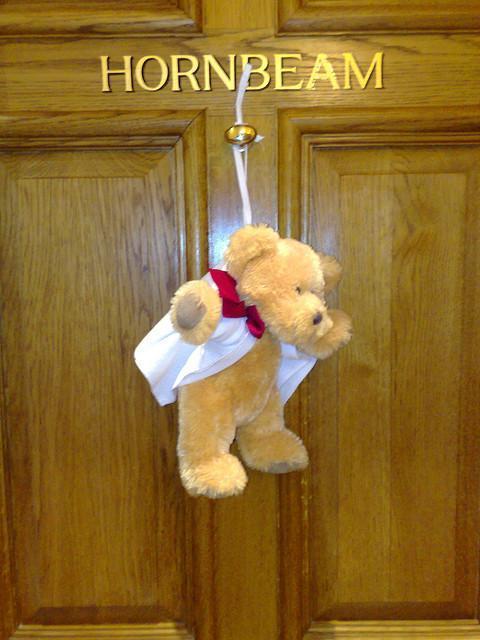How many teddy bears are visible?
Give a very brief answer. 1. How many women are in the image?
Give a very brief answer. 0. 